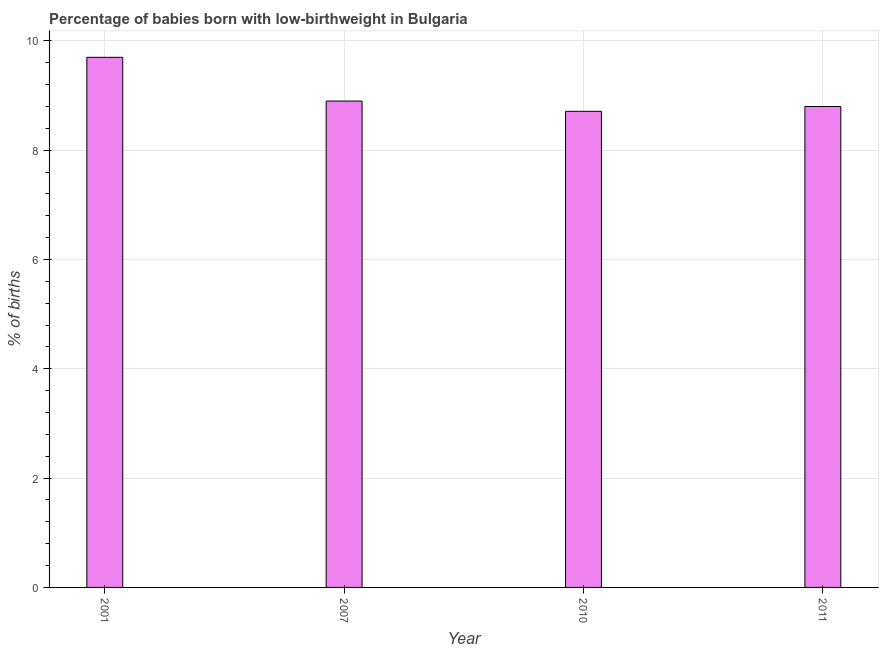Does the graph contain any zero values?
Offer a terse response. No. Does the graph contain grids?
Make the answer very short. Yes. What is the title of the graph?
Your answer should be very brief. Percentage of babies born with low-birthweight in Bulgaria. What is the label or title of the Y-axis?
Provide a succinct answer. % of births. What is the percentage of babies who were born with low-birthweight in 2001?
Offer a very short reply. 9.7. Across all years, what is the maximum percentage of babies who were born with low-birthweight?
Provide a short and direct response. 9.7. Across all years, what is the minimum percentage of babies who were born with low-birthweight?
Offer a terse response. 8.71. What is the sum of the percentage of babies who were born with low-birthweight?
Provide a short and direct response. 36.11. What is the difference between the percentage of babies who were born with low-birthweight in 2010 and 2011?
Offer a very short reply. -0.09. What is the average percentage of babies who were born with low-birthweight per year?
Offer a terse response. 9.03. What is the median percentage of babies who were born with low-birthweight?
Keep it short and to the point. 8.85. What is the ratio of the percentage of babies who were born with low-birthweight in 2007 to that in 2010?
Make the answer very short. 1.02. Is the difference between the percentage of babies who were born with low-birthweight in 2010 and 2011 greater than the difference between any two years?
Offer a terse response. No. In how many years, is the percentage of babies who were born with low-birthweight greater than the average percentage of babies who were born with low-birthweight taken over all years?
Your answer should be compact. 1. How many bars are there?
Offer a very short reply. 4. How many years are there in the graph?
Provide a short and direct response. 4. What is the difference between two consecutive major ticks on the Y-axis?
Your response must be concise. 2. What is the % of births in 2001?
Your response must be concise. 9.7. What is the % of births in 2010?
Your response must be concise. 8.71. What is the % of births in 2011?
Provide a succinct answer. 8.8. What is the difference between the % of births in 2001 and 2010?
Your answer should be compact. 0.99. What is the difference between the % of births in 2007 and 2010?
Keep it short and to the point. 0.19. What is the difference between the % of births in 2010 and 2011?
Your response must be concise. -0.09. What is the ratio of the % of births in 2001 to that in 2007?
Offer a terse response. 1.09. What is the ratio of the % of births in 2001 to that in 2010?
Your answer should be compact. 1.11. What is the ratio of the % of births in 2001 to that in 2011?
Your answer should be compact. 1.1. What is the ratio of the % of births in 2007 to that in 2010?
Ensure brevity in your answer.  1.02. What is the ratio of the % of births in 2007 to that in 2011?
Your answer should be compact. 1.01. 